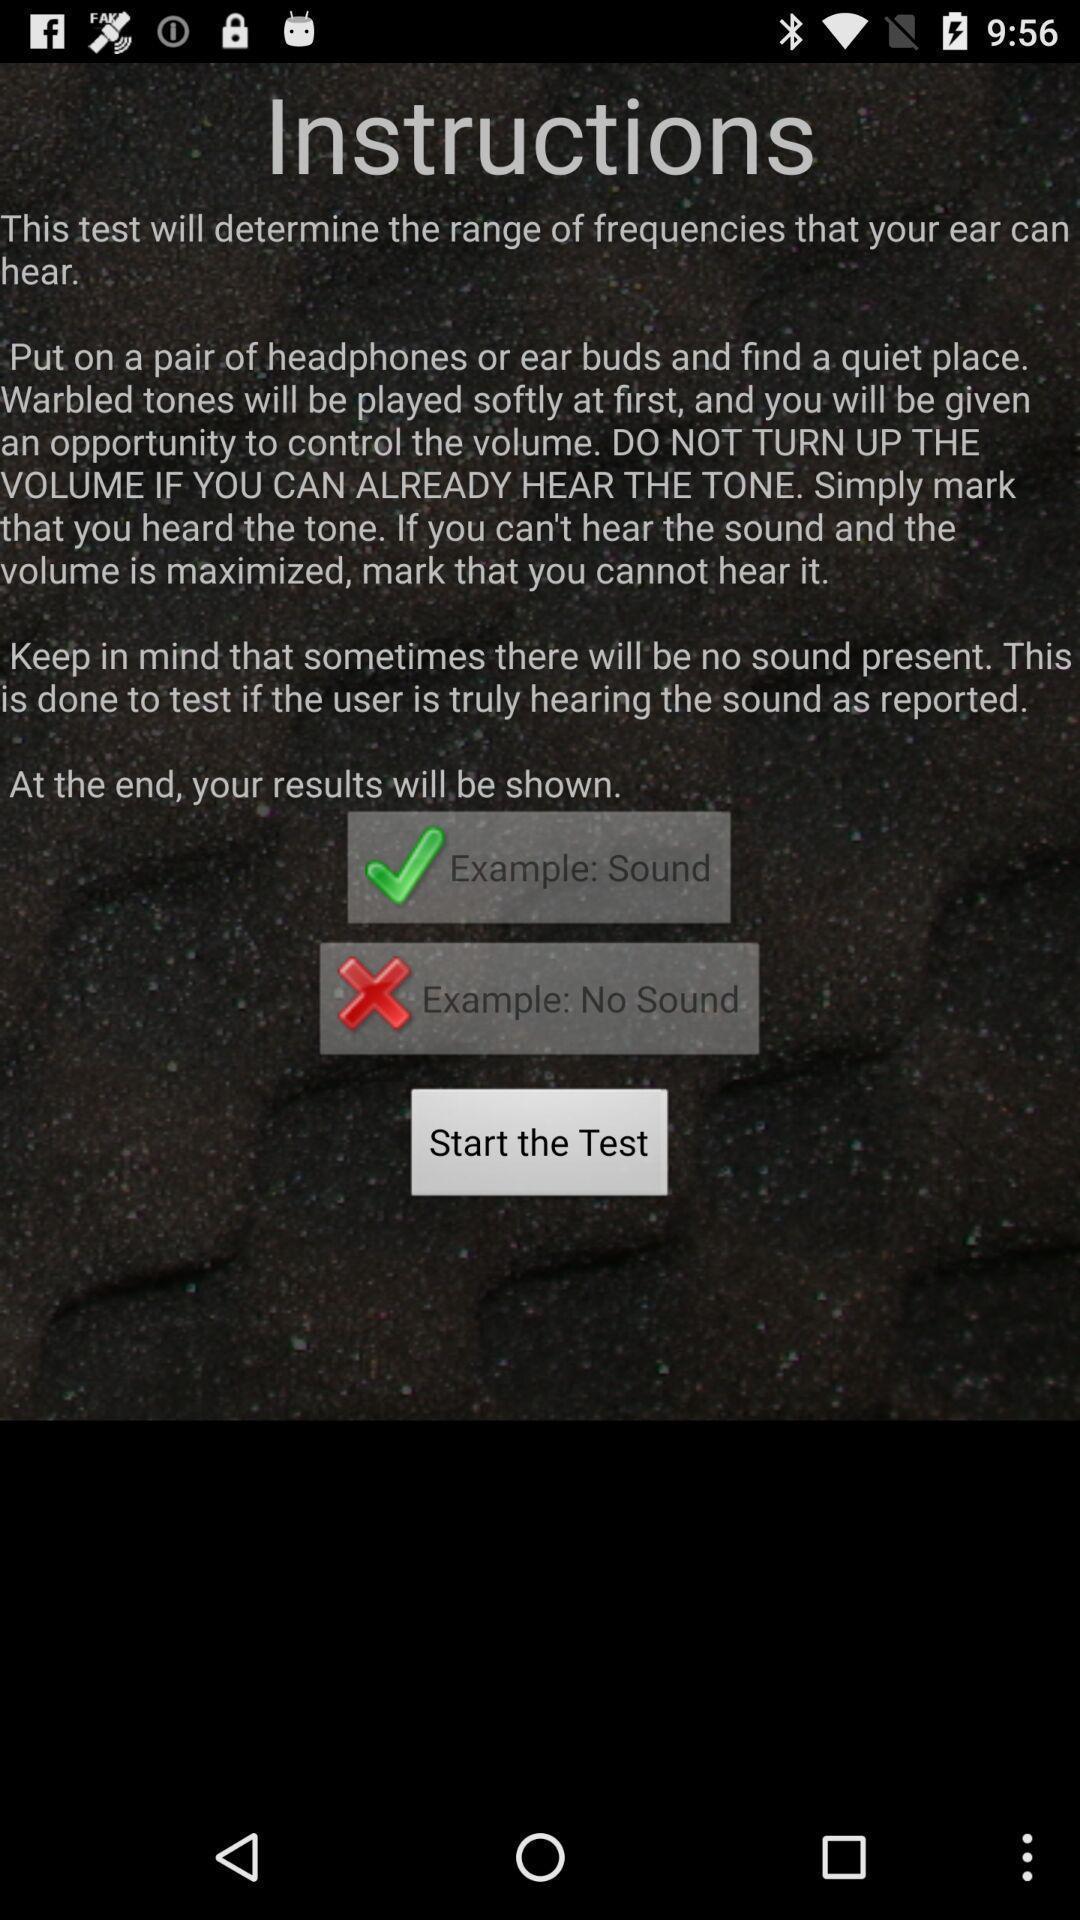Summarize the information in this screenshot. Screen shows instructions for hear testing. 